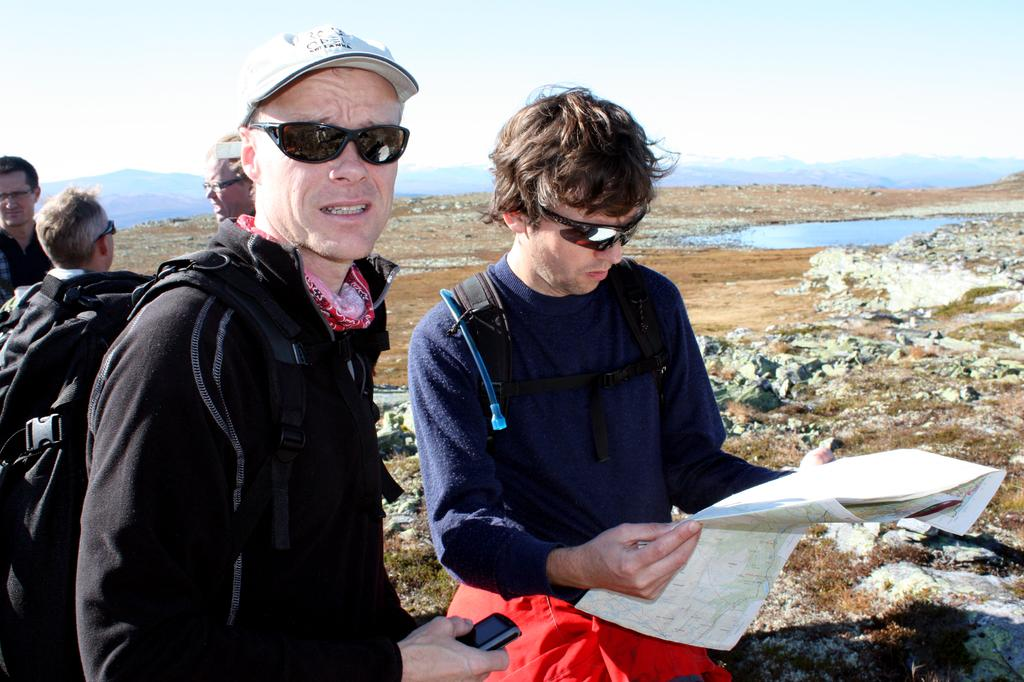What are the people in the image doing? The people in the image are standing in the center. What can be seen in the background of the image? There are mountains in the background of the image. What natural element is visible in the image? There is water visible in the image. What type of surface is at the bottom of the image? There are stones at the bottom of the image. What type of jewel is being cut with the scissors in the image? There are no jewels or scissors present in the image. 